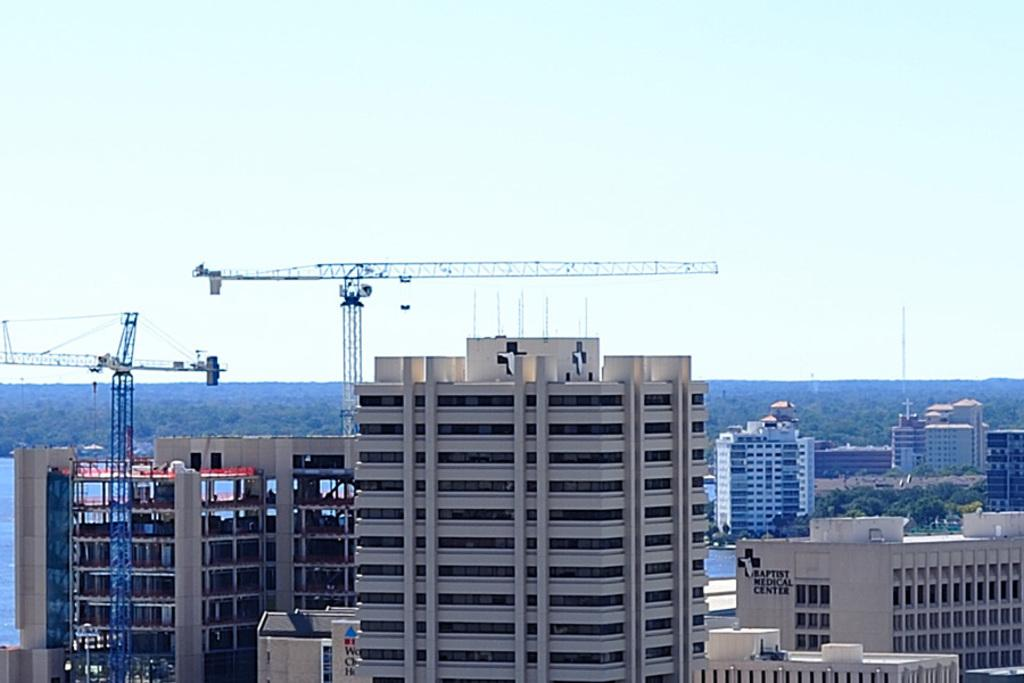What is visible in the center of the image? The sky is visible in the center of the image. What type of structures can be seen in the image? There are buildings and pole-type structures in the image. What other natural elements are present in the image? Trees are visible in the image. Can you describe any other objects in the image? There are a few other objects in the image. What type of degree is being awarded at the party in the image? There is no party or degree present in the image. What emotion is being expressed by the trees in the image? Trees do not express emotions, so this question cannot be answered. 